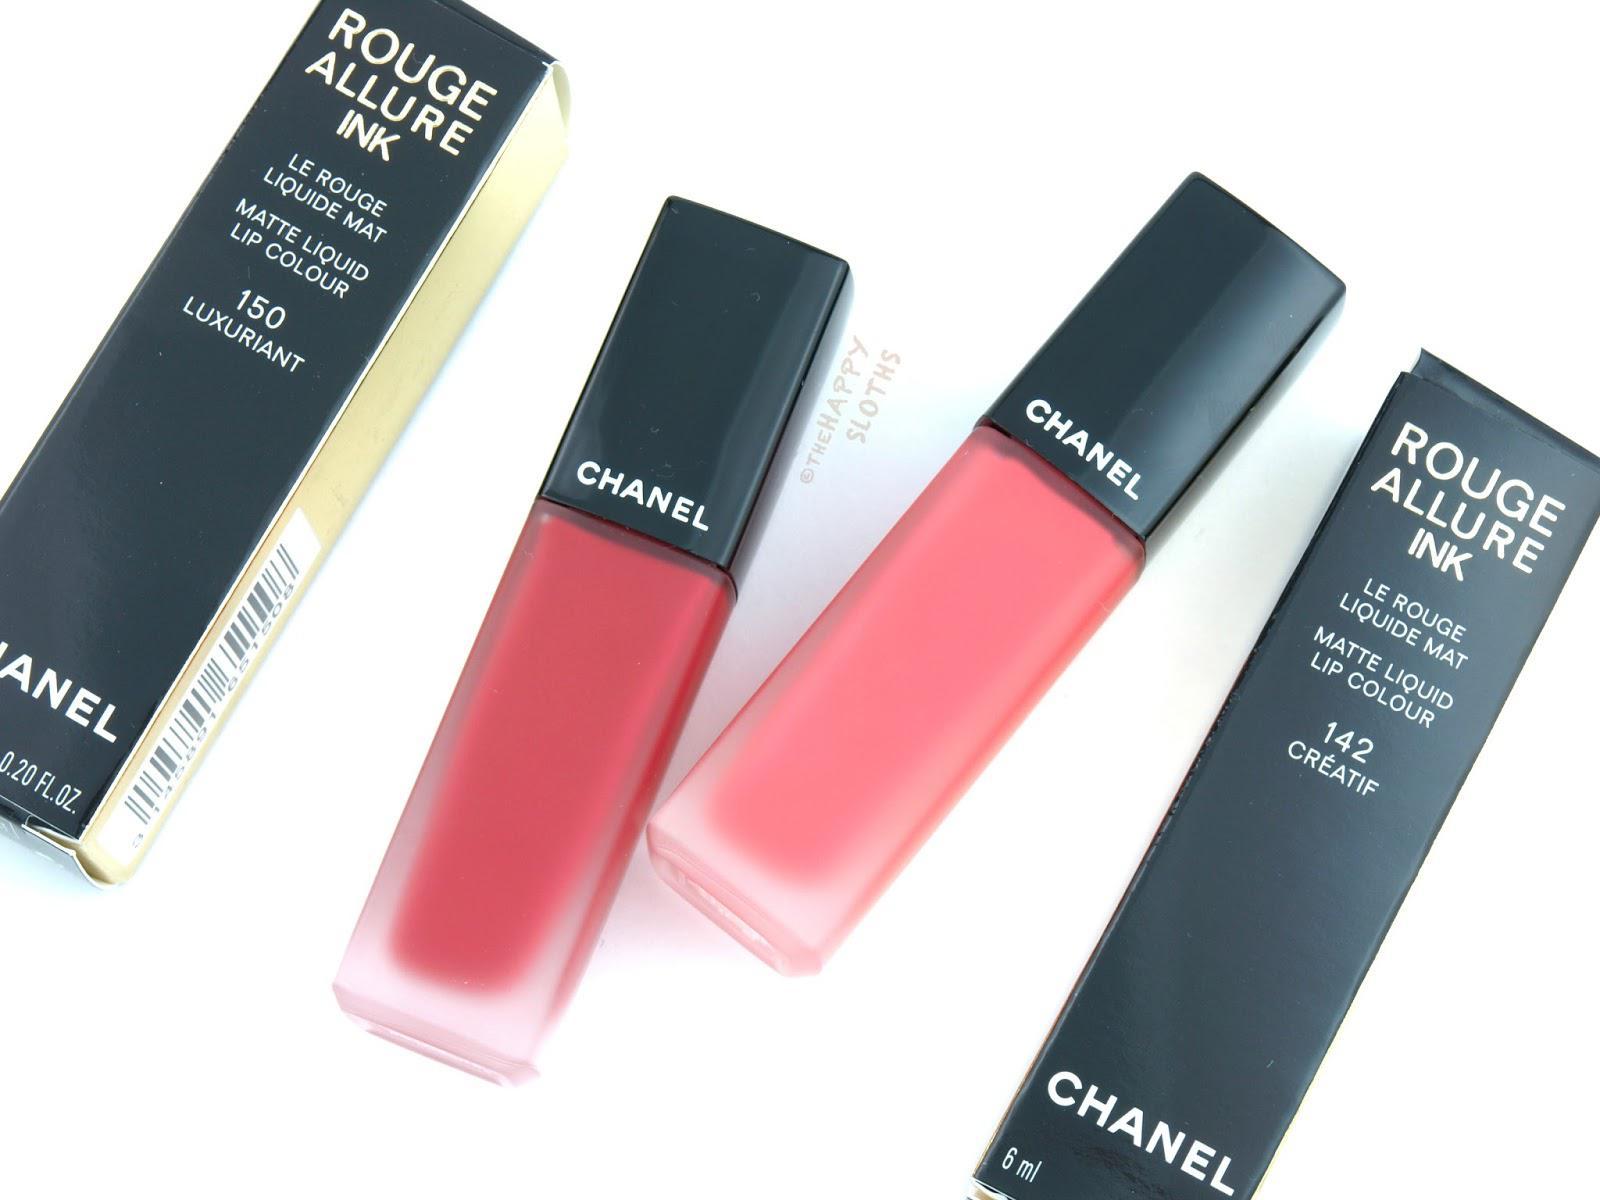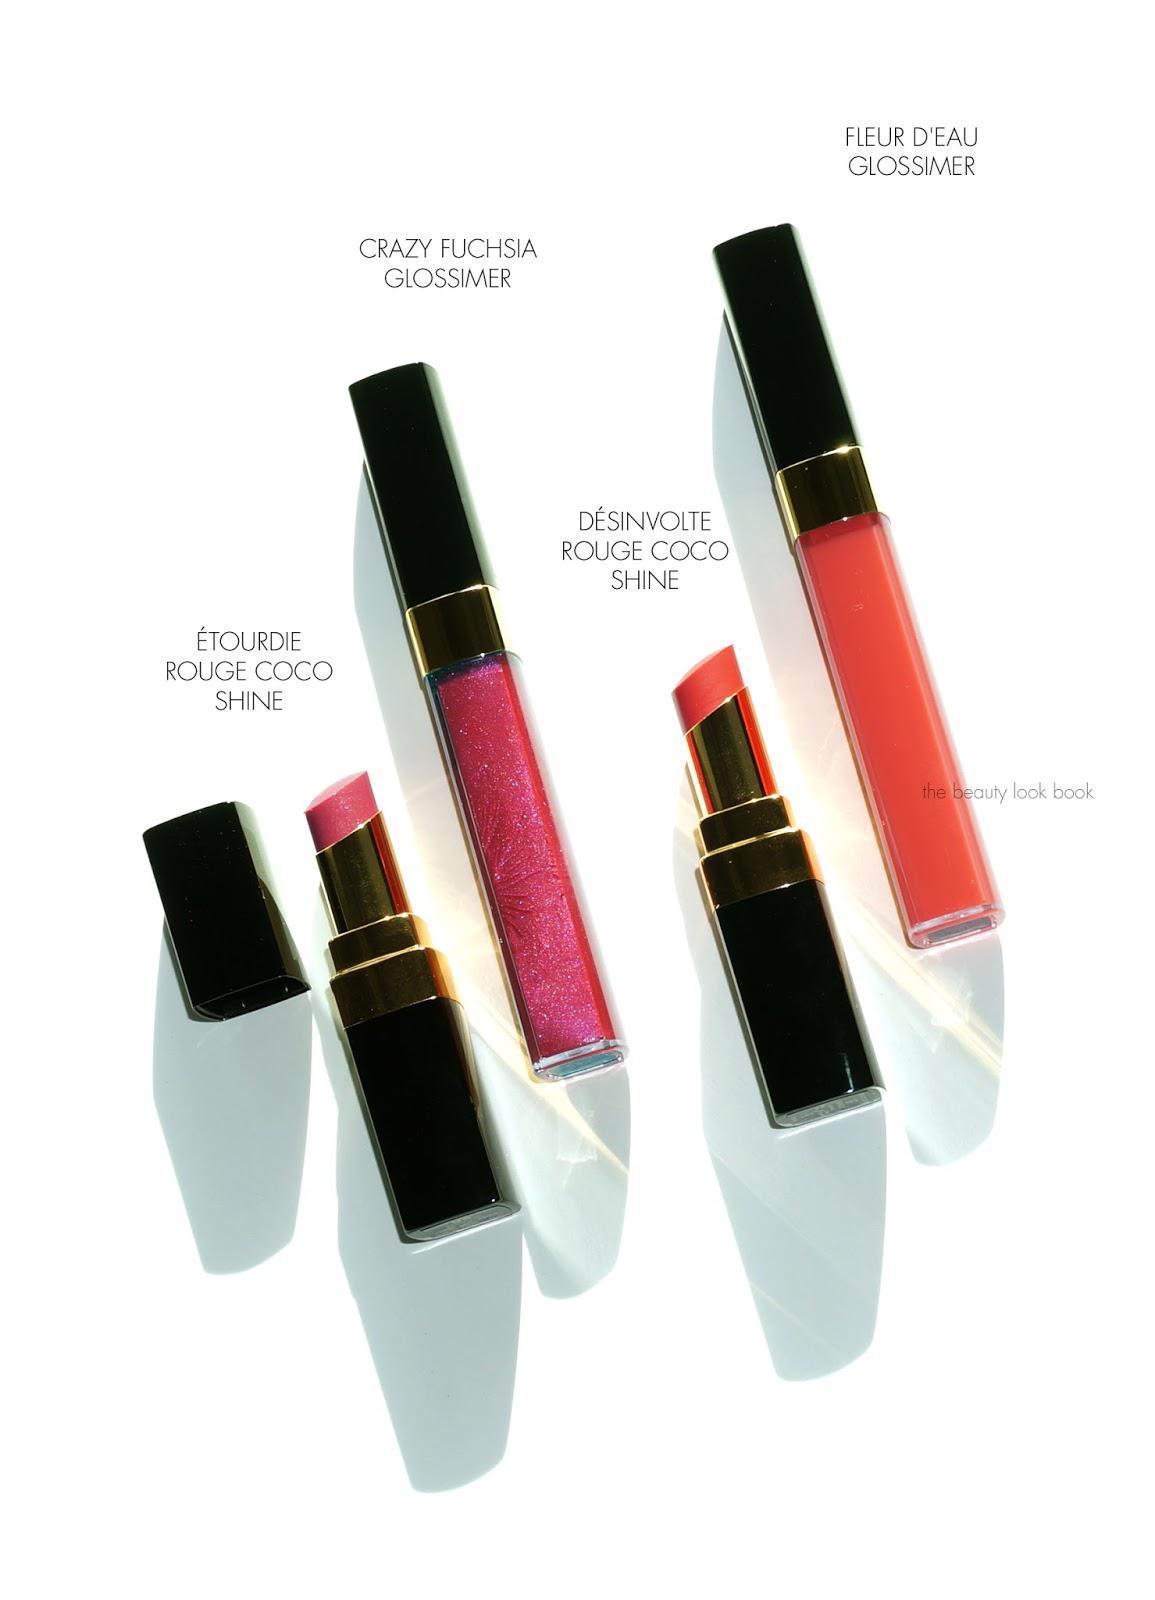The first image is the image on the left, the second image is the image on the right. Considering the images on both sides, is "One of the images has only two makeups, and the" valid? Answer yes or no. No. The first image is the image on the left, the second image is the image on the right. Evaluate the accuracy of this statement regarding the images: "At least one of the images is of Dior lipstick colors". Is it true? Answer yes or no. No. 